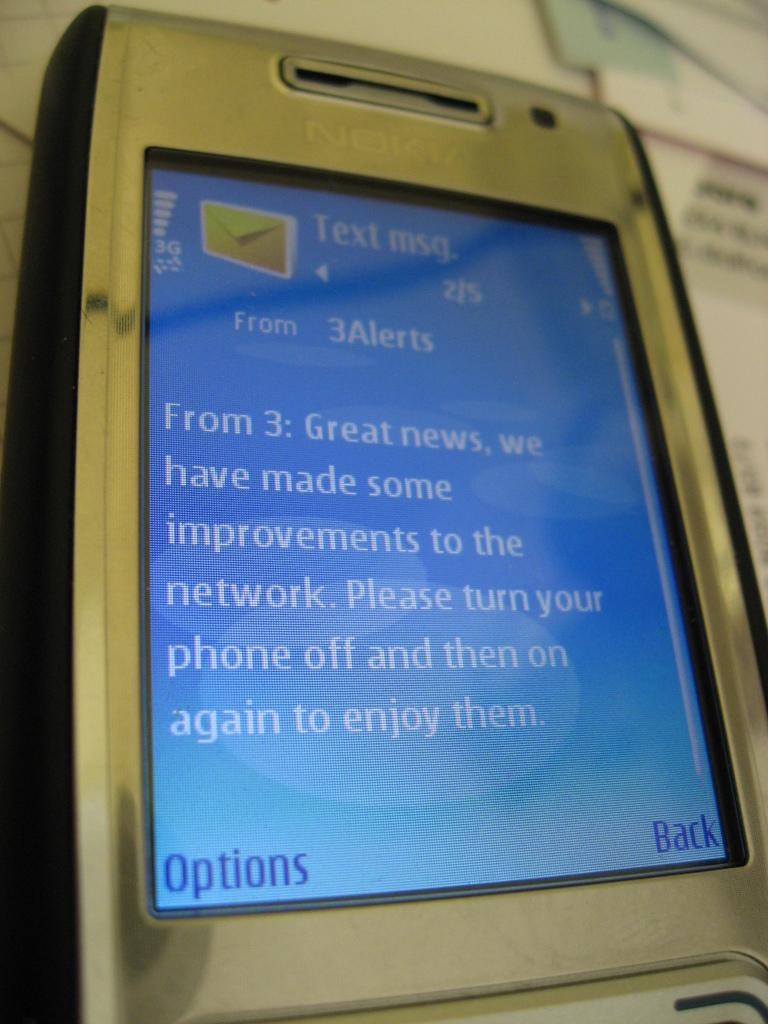<image>
Give a short and clear explanation of the subsequent image. The text message is from the user 3Alerts 